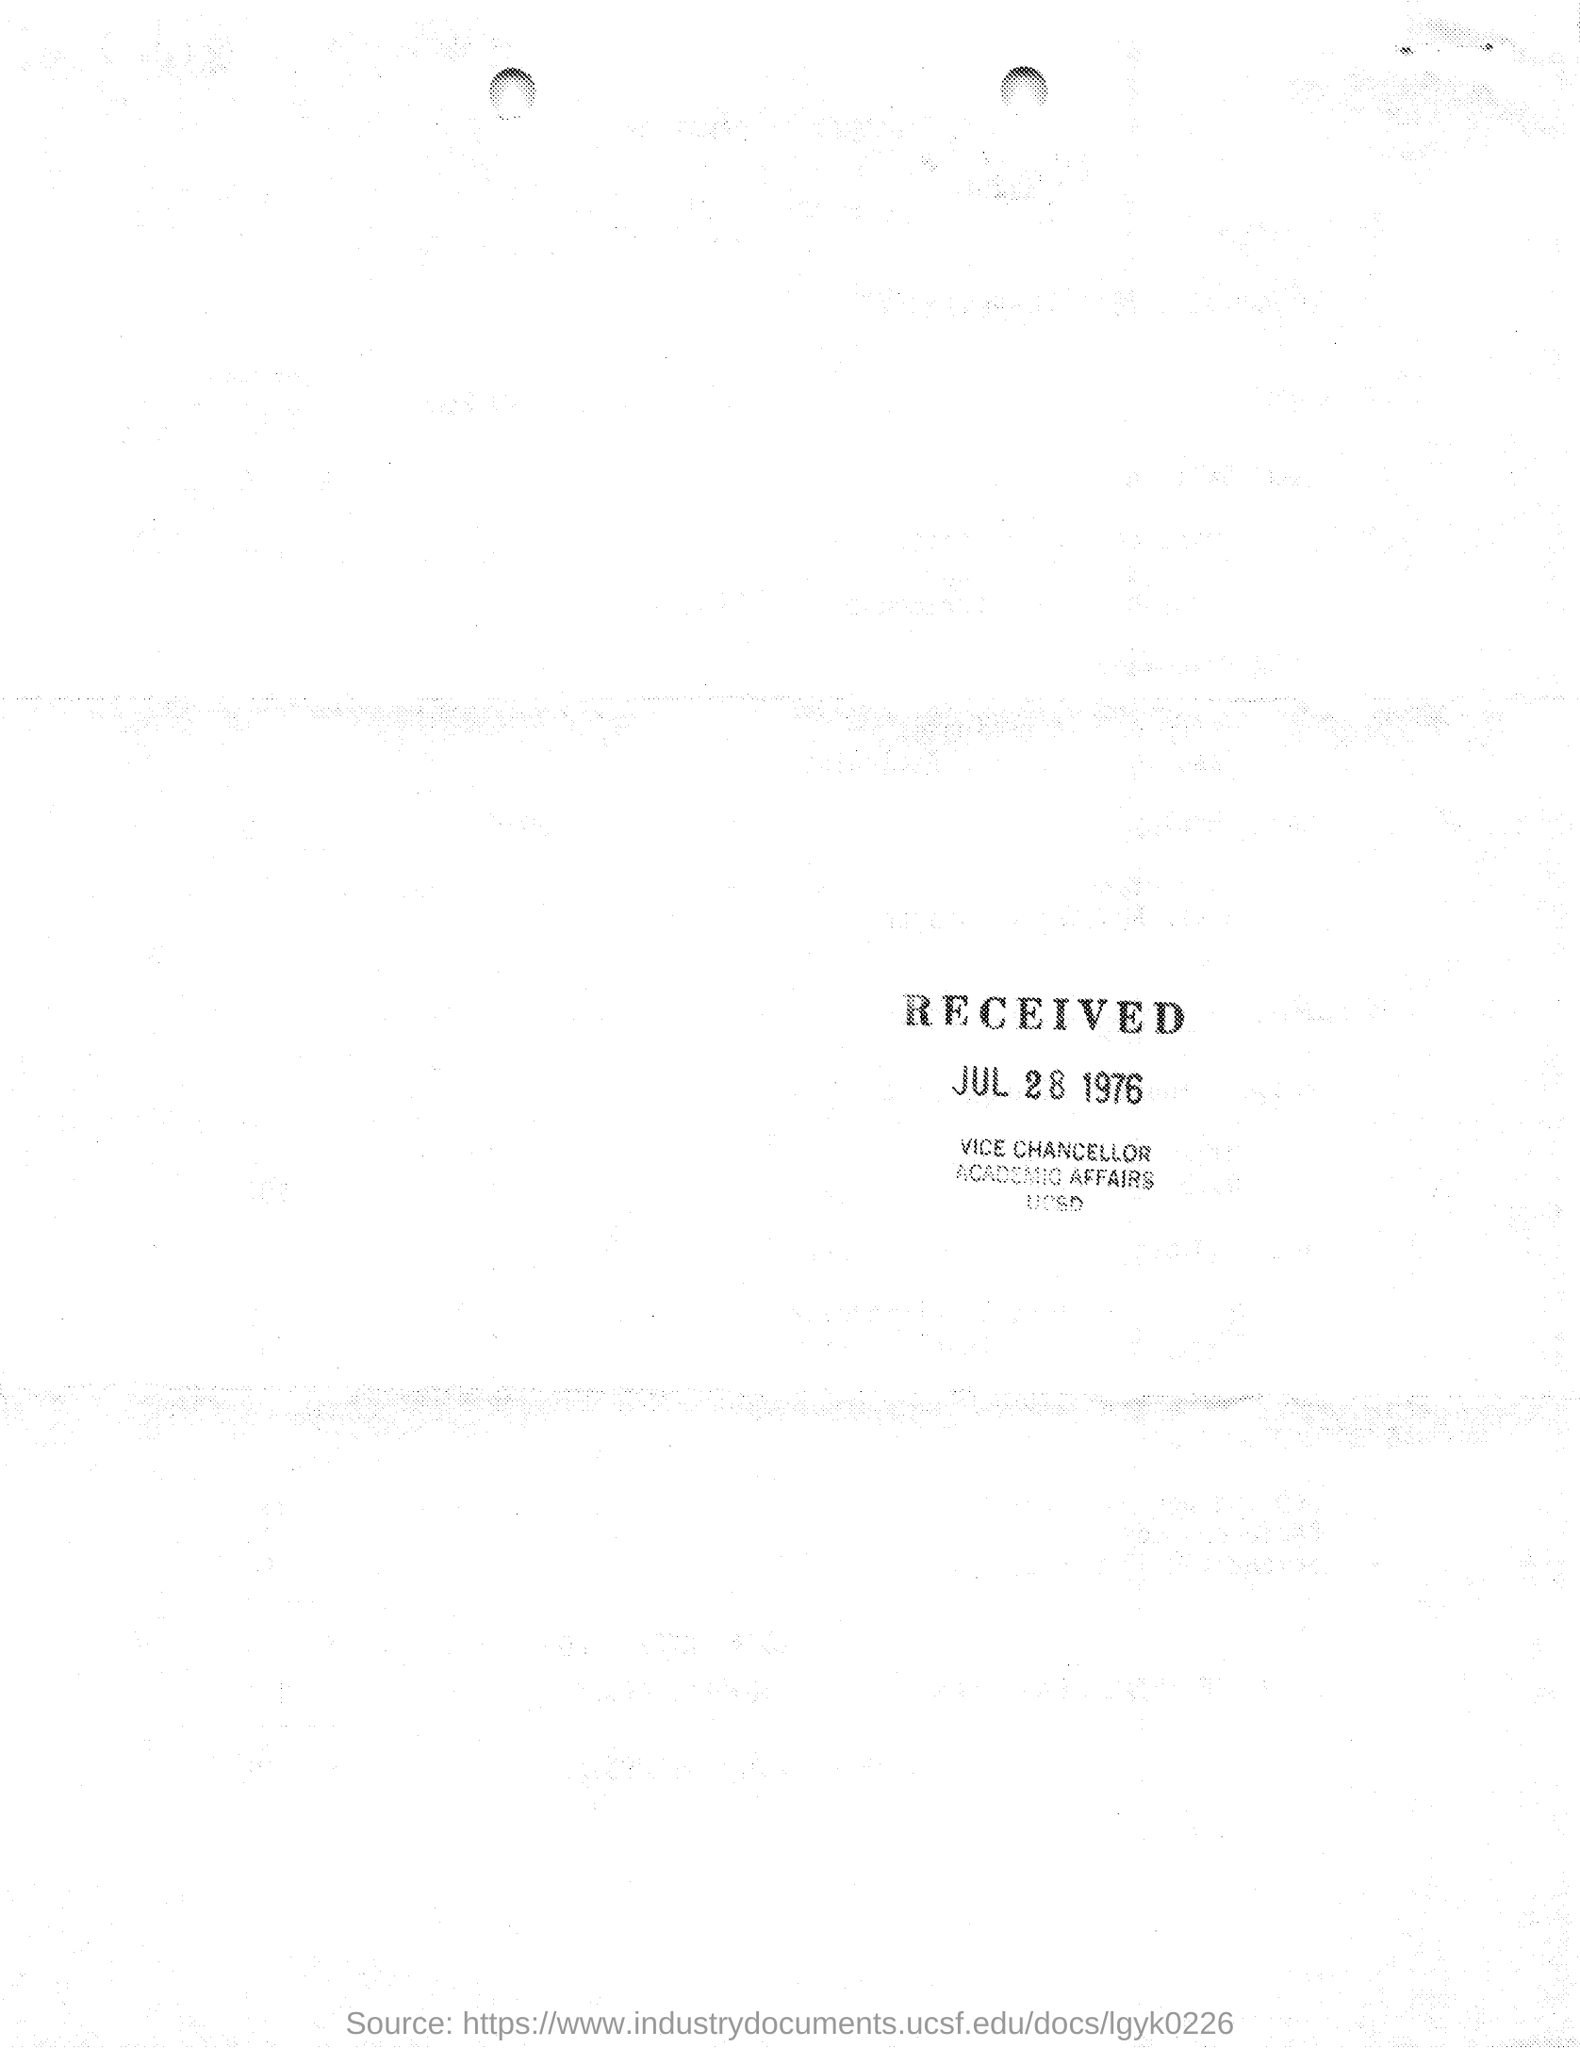When did this received?
Your answer should be very brief. Jul 28 1976. Who has issued this?
Keep it short and to the point. Vice chancellor. 